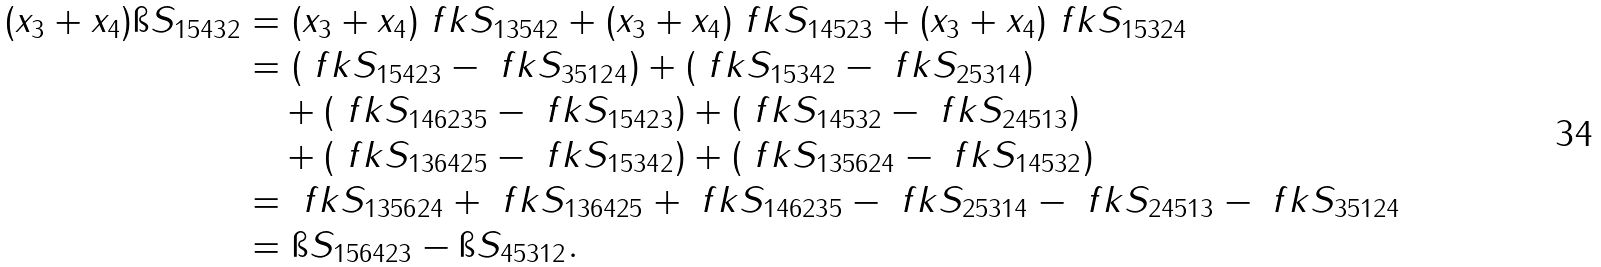Convert formula to latex. <formula><loc_0><loc_0><loc_500><loc_500>( x _ { 3 } + x _ { 4 } ) \i S _ { 1 5 4 3 2 } & = ( x _ { 3 } + x _ { 4 } ) \ f k S _ { 1 3 5 4 2 } + ( x _ { 3 } + x _ { 4 } ) \ f k S _ { 1 4 5 2 3 } + ( x _ { 3 } + x _ { 4 } ) \ f k S _ { 1 5 3 2 4 } \\ & = ( \ f k S _ { 1 5 4 2 3 } - \ f k S _ { 3 5 1 2 4 } ) + ( \ f k S _ { 1 5 3 4 2 } - \ f k S _ { 2 5 3 1 4 } ) \\ & \quad + ( \ f k S _ { 1 4 6 2 3 5 } - \ f k S _ { 1 5 4 2 3 } ) + ( \ f k S _ { 1 4 5 3 2 } - \ f k S _ { 2 4 5 1 3 } ) \\ & \quad + ( \ f k S _ { 1 3 6 4 2 5 } - \ f k S _ { 1 5 3 4 2 } ) + ( \ f k S _ { 1 3 5 6 2 4 } - \ f k S _ { 1 4 5 3 2 } ) \\ & = \ f k S _ { 1 3 5 6 2 4 } + \ f k S _ { 1 3 6 4 2 5 } + \ f k S _ { 1 4 6 2 3 5 } - \ f k S _ { 2 5 3 1 4 } - \ f k S _ { 2 4 5 1 3 } - \ f k S _ { 3 5 1 2 4 } \\ & = \i S _ { 1 5 6 4 2 3 } - \i S _ { 4 5 3 1 2 } .</formula> 